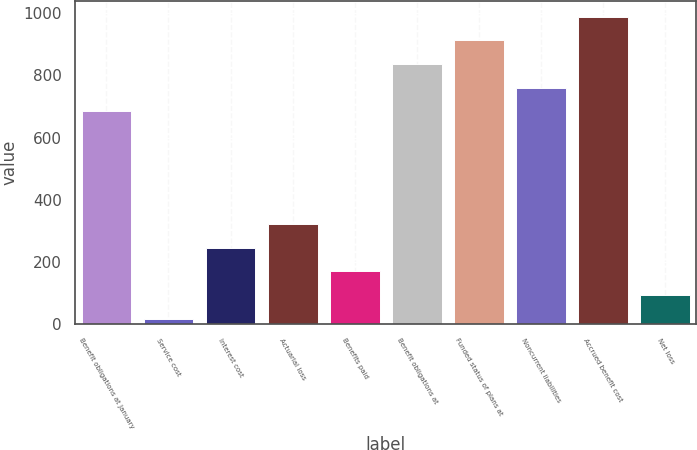Convert chart to OTSL. <chart><loc_0><loc_0><loc_500><loc_500><bar_chart><fcel>Benefit obligations at January<fcel>Service cost<fcel>Interest cost<fcel>Actuarial loss<fcel>Benefits paid<fcel>Benefit obligations at<fcel>Funded status of plans at<fcel>Noncurrent liabilities<fcel>Accrued benefit cost<fcel>Net loss<nl><fcel>685<fcel>18<fcel>246.3<fcel>322.4<fcel>170.2<fcel>837.2<fcel>913.3<fcel>761.1<fcel>989.4<fcel>94.1<nl></chart> 